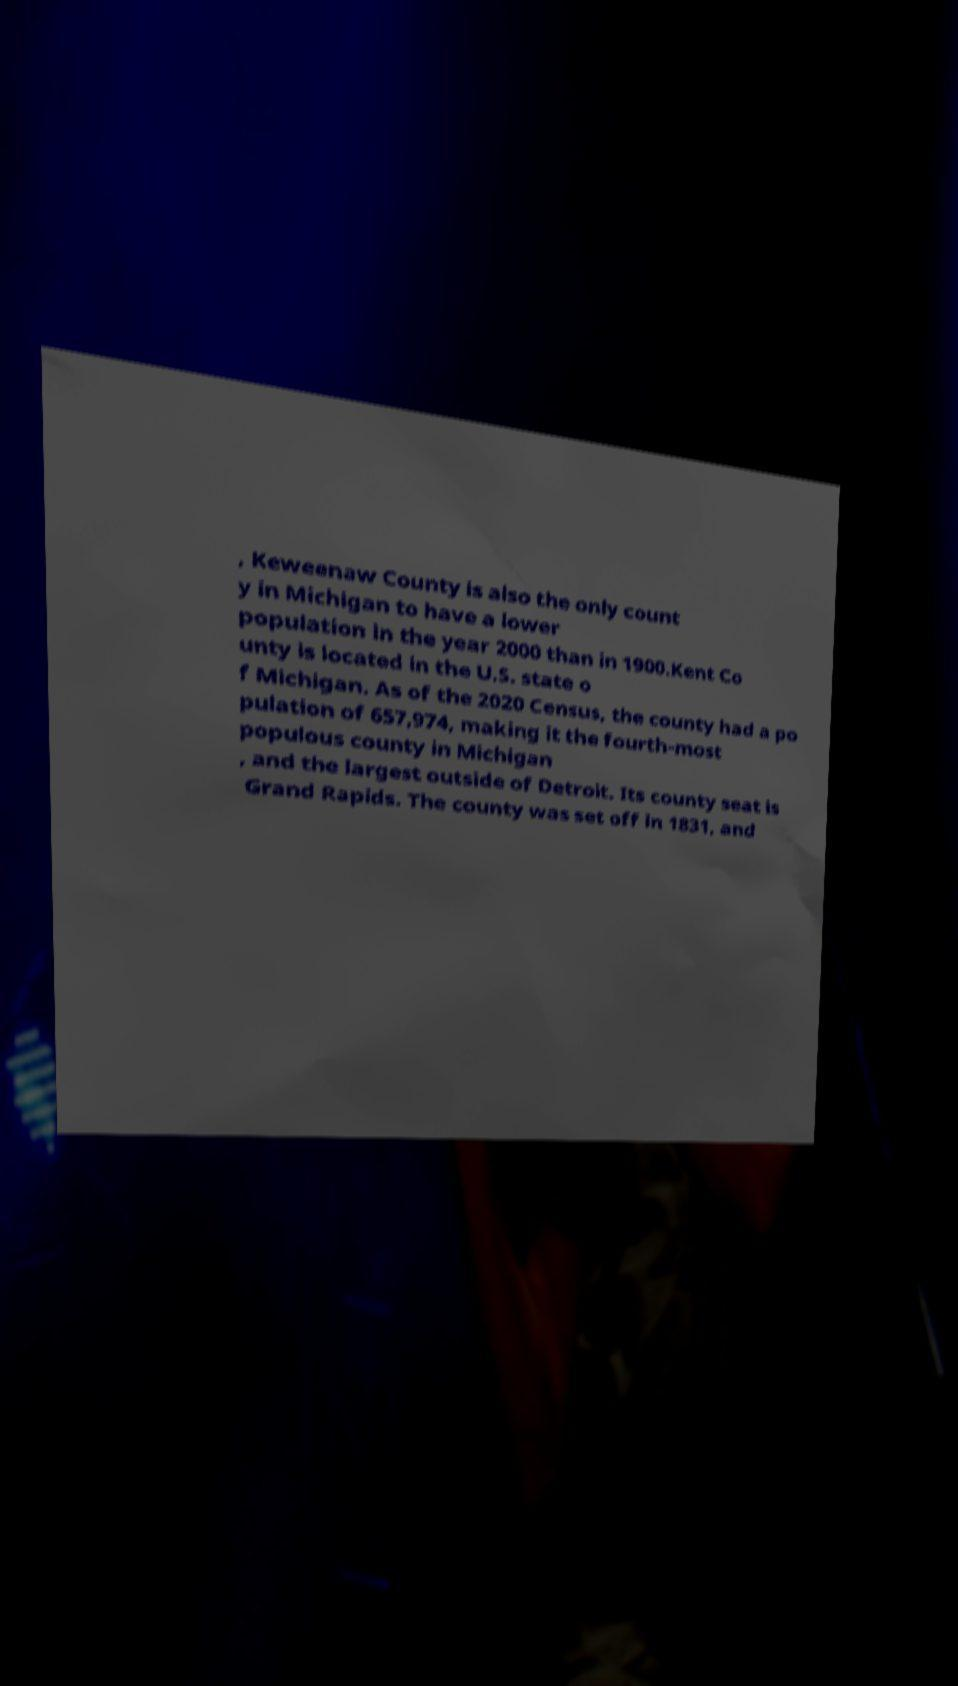There's text embedded in this image that I need extracted. Can you transcribe it verbatim? , Keweenaw County is also the only count y in Michigan to have a lower population in the year 2000 than in 1900.Kent Co unty is located in the U.S. state o f Michigan. As of the 2020 Census, the county had a po pulation of 657,974, making it the fourth-most populous county in Michigan , and the largest outside of Detroit. Its county seat is Grand Rapids. The county was set off in 1831, and 